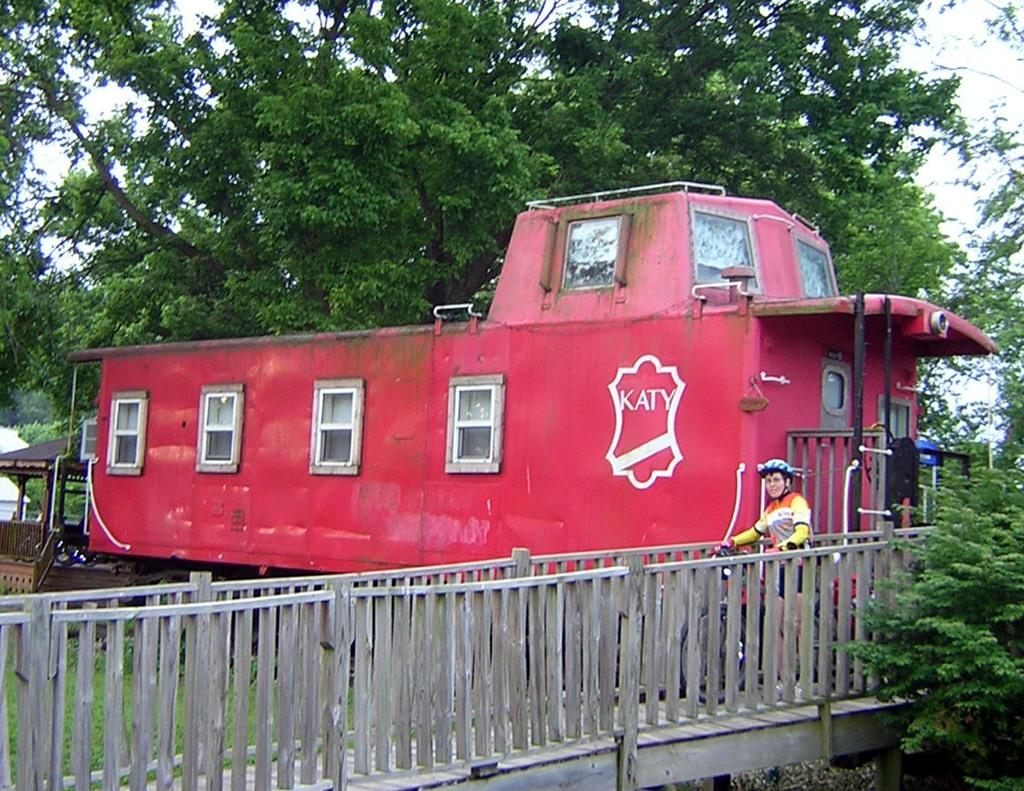What is the main subject in the image? There is a vehicle in the image. Can you describe the person in the image? There is a person in the image. What type of structure can be seen in the image? There are railings and a shelter in the image. What type of natural environment is visible in the image? There are trees and grass in the image. What is visible in the background of the image? The sky is visible through the trees in the image. How many objects can be seen in the image? There are objects in the image. What language is the person speaking in the image? There is no indication of the person speaking in the image, so it cannot be determined what language they might be using. 